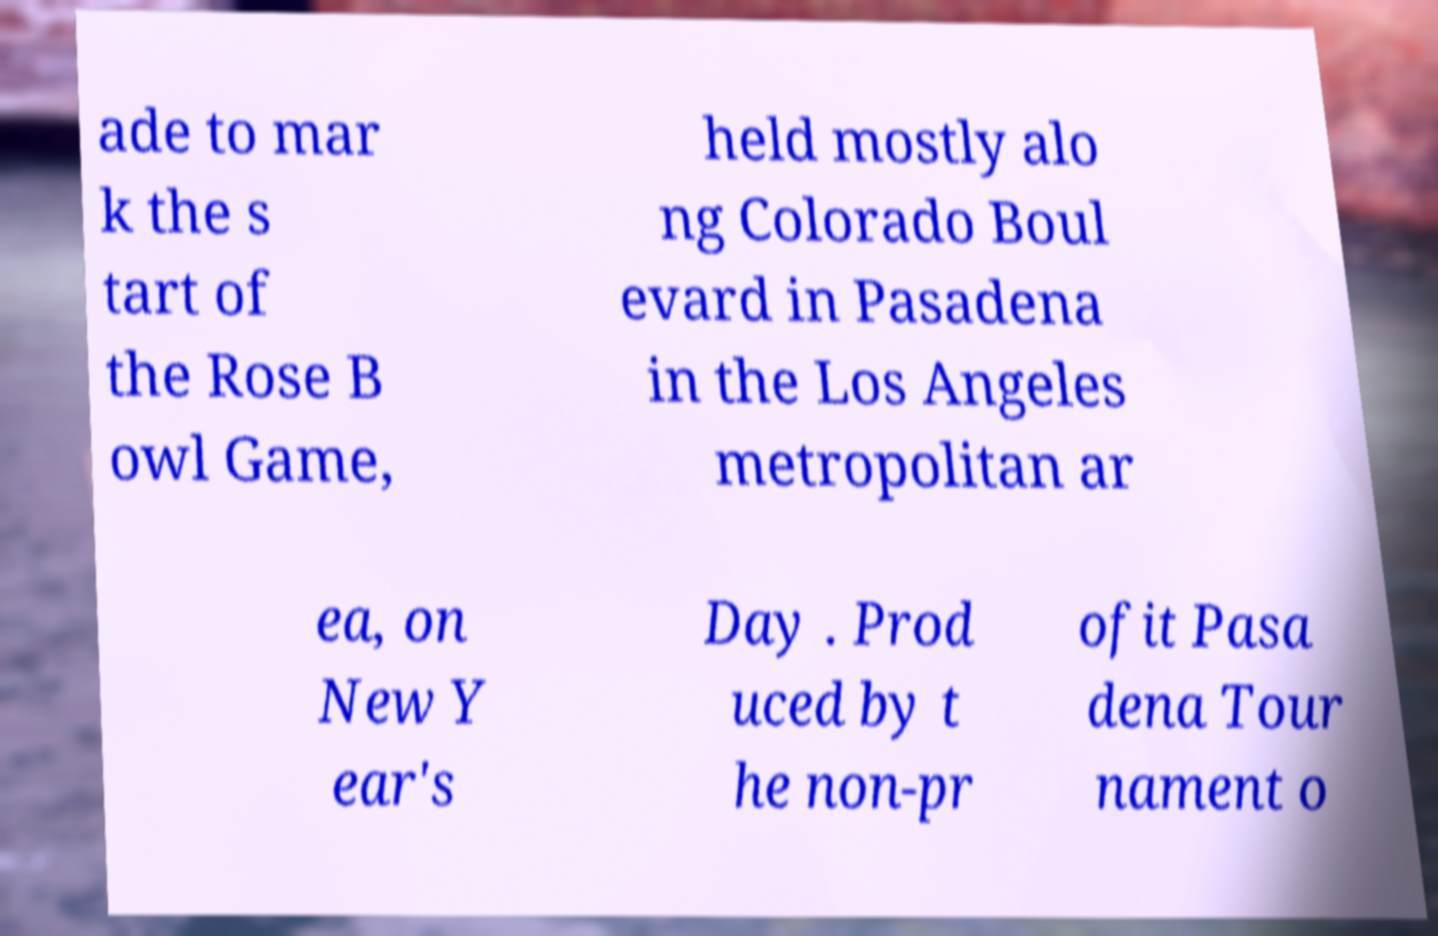Could you assist in decoding the text presented in this image and type it out clearly? ade to mar k the s tart of the Rose B owl Game, held mostly alo ng Colorado Boul evard in Pasadena in the Los Angeles metropolitan ar ea, on New Y ear's Day . Prod uced by t he non-pr ofit Pasa dena Tour nament o 